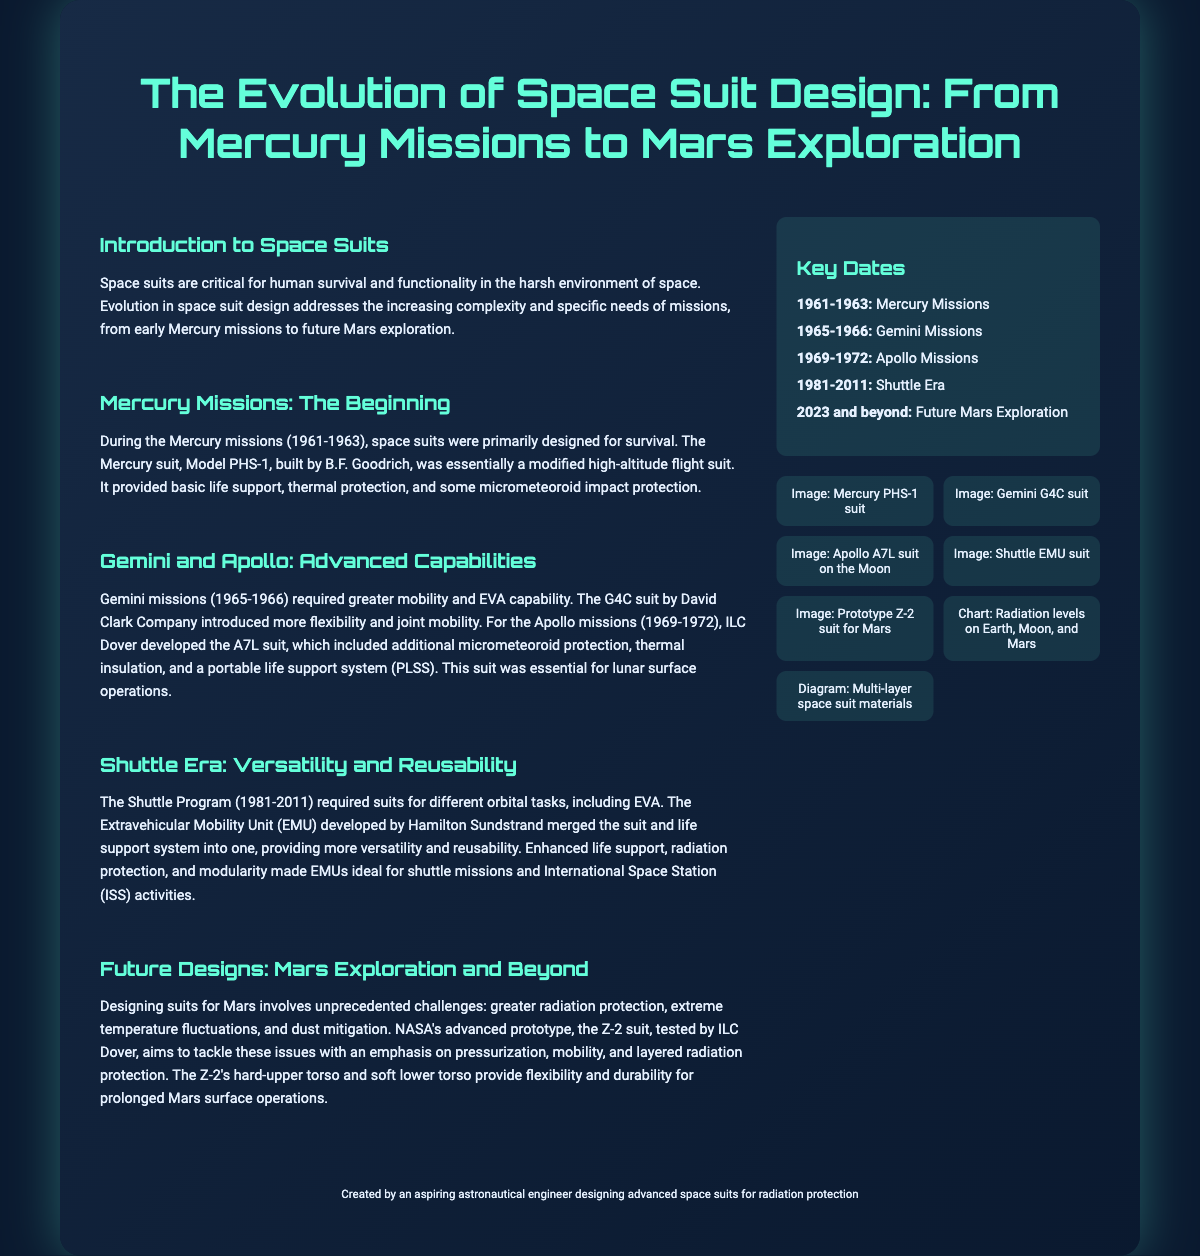what was the primary design focus of Mercury suits? The primary design focus of Mercury suits was survival in space.
Answer: survival which company developed the Apollo A7L suit? The Apollo A7L suit was developed by ILC Dover.
Answer: ILC Dover what does EMU stand for in the context of space suits? EMU stands for Extravehicular Mobility Unit.
Answer: Extravehicular Mobility Unit how many years did the Shuttle Program last? The Shuttle Program lasted for 30 years, from 1981 to 2011.
Answer: 30 years what major challenge do Mars suits need to address? Mars suits need to address greater radiation protection.
Answer: radiation protection when were the Gemini missions conducted? The Gemini missions were conducted from 1965 to 1966.
Answer: 1965-1966 what feature does the Z-2 suit emphasize for Mars operations? The Z-2 suit emphasizes pressurization for Mars operations.
Answer: pressurization how many key dates are mentioned in the timeline? There are five key dates mentioned in the timeline.
Answer: five which suit was a modified high-altitude flight suit? The Mercury suit Model PHS-1 was essentially a modified high-altitude flight suit.
Answer: Mercury suit Model PHS-1 